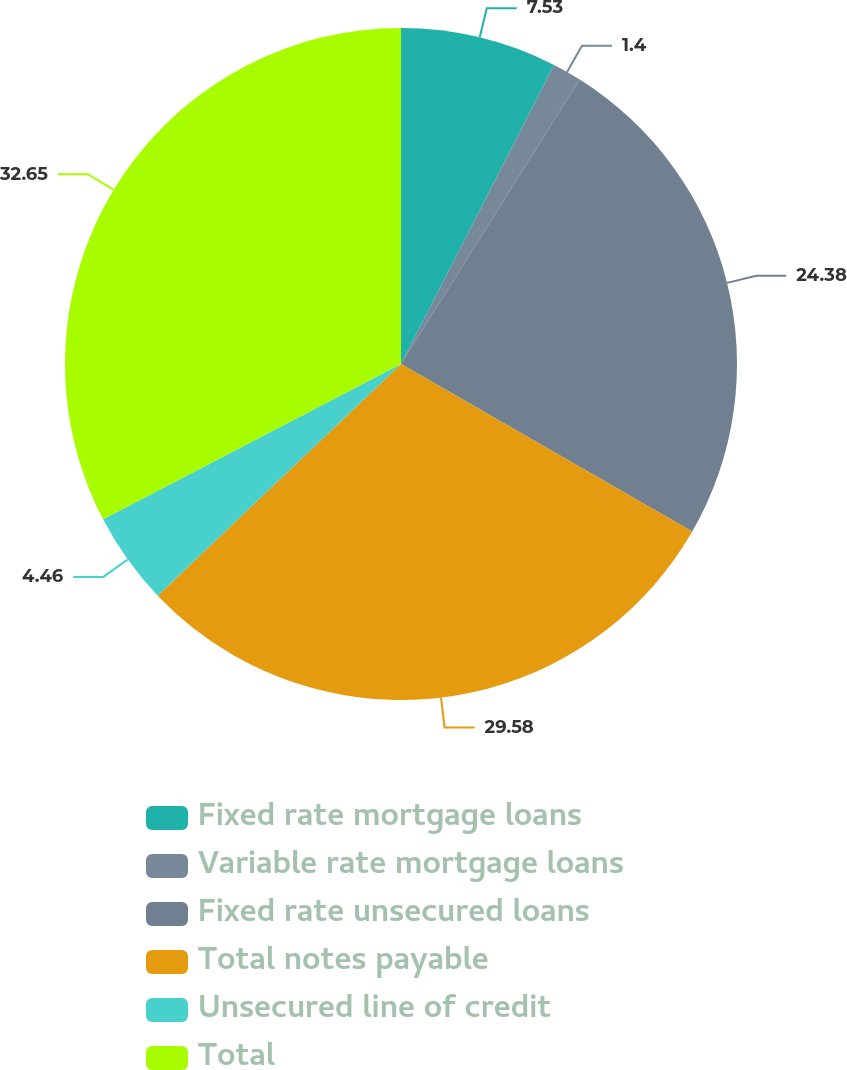Convert chart to OTSL. <chart><loc_0><loc_0><loc_500><loc_500><pie_chart><fcel>Fixed rate mortgage loans<fcel>Variable rate mortgage loans<fcel>Fixed rate unsecured loans<fcel>Total notes payable<fcel>Unsecured line of credit<fcel>Total<nl><fcel>7.53%<fcel>1.4%<fcel>24.38%<fcel>29.58%<fcel>4.46%<fcel>32.65%<nl></chart> 